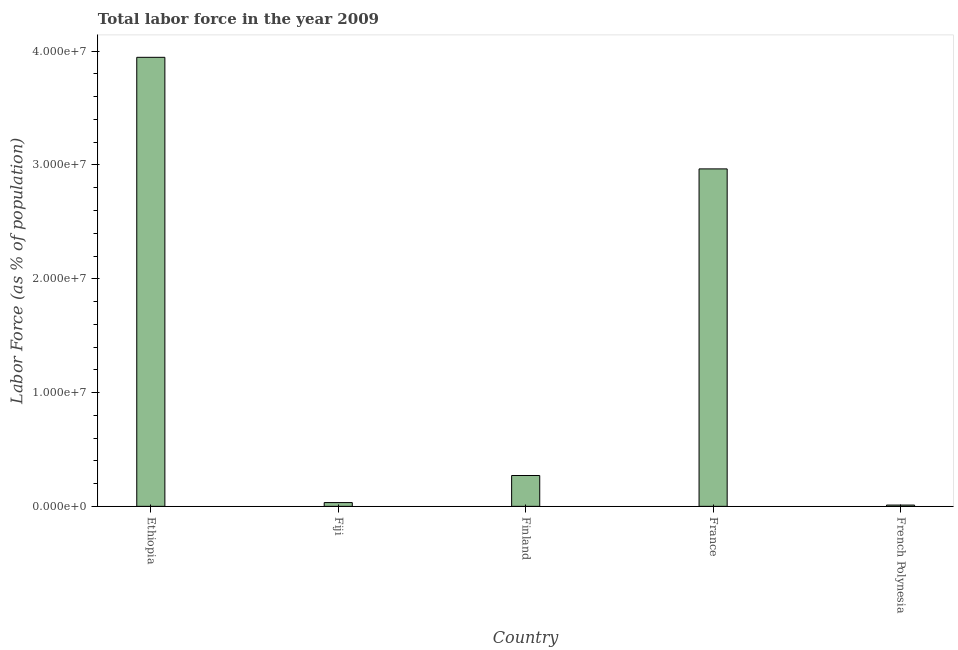What is the title of the graph?
Your answer should be compact. Total labor force in the year 2009. What is the label or title of the X-axis?
Keep it short and to the point. Country. What is the label or title of the Y-axis?
Offer a terse response. Labor Force (as % of population). What is the total labor force in Ethiopia?
Give a very brief answer. 3.95e+07. Across all countries, what is the maximum total labor force?
Your answer should be very brief. 3.95e+07. Across all countries, what is the minimum total labor force?
Make the answer very short. 1.12e+05. In which country was the total labor force maximum?
Your response must be concise. Ethiopia. In which country was the total labor force minimum?
Your answer should be compact. French Polynesia. What is the sum of the total labor force?
Offer a terse response. 7.23e+07. What is the difference between the total labor force in Ethiopia and Fiji?
Provide a short and direct response. 3.91e+07. What is the average total labor force per country?
Make the answer very short. 1.45e+07. What is the median total labor force?
Offer a very short reply. 2.71e+06. What is the ratio of the total labor force in Ethiopia to that in French Polynesia?
Your response must be concise. 352.36. What is the difference between the highest and the second highest total labor force?
Offer a terse response. 9.81e+06. What is the difference between the highest and the lowest total labor force?
Your response must be concise. 3.93e+07. In how many countries, is the total labor force greater than the average total labor force taken over all countries?
Make the answer very short. 2. How many bars are there?
Your answer should be compact. 5. Are all the bars in the graph horizontal?
Offer a very short reply. No. How many countries are there in the graph?
Make the answer very short. 5. What is the Labor Force (as % of population) in Ethiopia?
Your answer should be compact. 3.95e+07. What is the Labor Force (as % of population) of Fiji?
Make the answer very short. 3.31e+05. What is the Labor Force (as % of population) of Finland?
Keep it short and to the point. 2.71e+06. What is the Labor Force (as % of population) in France?
Keep it short and to the point. 2.97e+07. What is the Labor Force (as % of population) of French Polynesia?
Your answer should be very brief. 1.12e+05. What is the difference between the Labor Force (as % of population) in Ethiopia and Fiji?
Give a very brief answer. 3.91e+07. What is the difference between the Labor Force (as % of population) in Ethiopia and Finland?
Give a very brief answer. 3.68e+07. What is the difference between the Labor Force (as % of population) in Ethiopia and France?
Make the answer very short. 9.81e+06. What is the difference between the Labor Force (as % of population) in Ethiopia and French Polynesia?
Offer a terse response. 3.93e+07. What is the difference between the Labor Force (as % of population) in Fiji and Finland?
Make the answer very short. -2.38e+06. What is the difference between the Labor Force (as % of population) in Fiji and France?
Give a very brief answer. -2.93e+07. What is the difference between the Labor Force (as % of population) in Fiji and French Polynesia?
Provide a short and direct response. 2.19e+05. What is the difference between the Labor Force (as % of population) in Finland and France?
Ensure brevity in your answer.  -2.69e+07. What is the difference between the Labor Force (as % of population) in Finland and French Polynesia?
Provide a short and direct response. 2.60e+06. What is the difference between the Labor Force (as % of population) in France and French Polynesia?
Offer a terse response. 2.95e+07. What is the ratio of the Labor Force (as % of population) in Ethiopia to that in Fiji?
Your answer should be compact. 119.25. What is the ratio of the Labor Force (as % of population) in Ethiopia to that in Finland?
Give a very brief answer. 14.56. What is the ratio of the Labor Force (as % of population) in Ethiopia to that in France?
Your answer should be compact. 1.33. What is the ratio of the Labor Force (as % of population) in Ethiopia to that in French Polynesia?
Your response must be concise. 352.36. What is the ratio of the Labor Force (as % of population) in Fiji to that in Finland?
Your answer should be very brief. 0.12. What is the ratio of the Labor Force (as % of population) in Fiji to that in France?
Offer a very short reply. 0.01. What is the ratio of the Labor Force (as % of population) in Fiji to that in French Polynesia?
Offer a very short reply. 2.96. What is the ratio of the Labor Force (as % of population) in Finland to that in France?
Keep it short and to the point. 0.09. What is the ratio of the Labor Force (as % of population) in Finland to that in French Polynesia?
Your response must be concise. 24.2. What is the ratio of the Labor Force (as % of population) in France to that in French Polynesia?
Offer a very short reply. 264.81. 